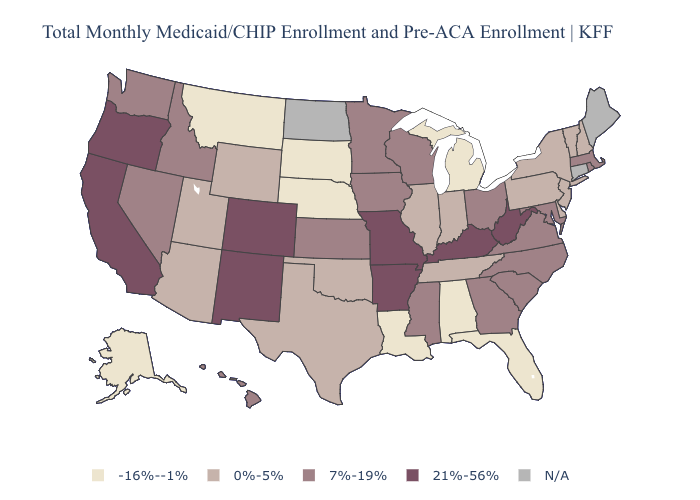Name the states that have a value in the range 21%-56%?
Concise answer only. Arkansas, California, Colorado, Kentucky, Missouri, New Mexico, Oregon, West Virginia. Name the states that have a value in the range 7%-19%?
Keep it brief. Georgia, Hawaii, Idaho, Iowa, Kansas, Maryland, Massachusetts, Minnesota, Mississippi, Nevada, North Carolina, Ohio, Rhode Island, South Carolina, Virginia, Washington, Wisconsin. What is the highest value in states that border Virginia?
Be succinct. 21%-56%. What is the lowest value in the USA?
Answer briefly. -16%--1%. What is the value of Texas?
Quick response, please. 0%-5%. Among the states that border Maryland , does Delaware have the lowest value?
Answer briefly. Yes. What is the lowest value in the USA?
Be succinct. -16%--1%. Name the states that have a value in the range -16%--1%?
Short answer required. Alabama, Alaska, Florida, Louisiana, Michigan, Montana, Nebraska, South Dakota. Which states have the lowest value in the USA?
Give a very brief answer. Alabama, Alaska, Florida, Louisiana, Michigan, Montana, Nebraska, South Dakota. What is the value of West Virginia?
Concise answer only. 21%-56%. What is the lowest value in states that border Illinois?
Answer briefly. 0%-5%. Does Michigan have the highest value in the MidWest?
Write a very short answer. No. Name the states that have a value in the range -16%--1%?
Be succinct. Alabama, Alaska, Florida, Louisiana, Michigan, Montana, Nebraska, South Dakota. Name the states that have a value in the range 7%-19%?
Concise answer only. Georgia, Hawaii, Idaho, Iowa, Kansas, Maryland, Massachusetts, Minnesota, Mississippi, Nevada, North Carolina, Ohio, Rhode Island, South Carolina, Virginia, Washington, Wisconsin. Name the states that have a value in the range -16%--1%?
Answer briefly. Alabama, Alaska, Florida, Louisiana, Michigan, Montana, Nebraska, South Dakota. 